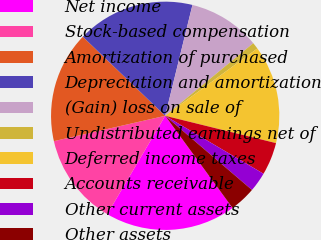<chart> <loc_0><loc_0><loc_500><loc_500><pie_chart><fcel>Net income<fcel>Stock-based compensation<fcel>Amortization of purchased<fcel>Depreciation and amortization<fcel>(Gain) loss on sale of<fcel>Undistributed earnings net of<fcel>Deferred income taxes<fcel>Accounts receivable<fcel>Other current assets<fcel>Other assets<nl><fcel>18.52%<fcel>12.96%<fcel>15.74%<fcel>16.67%<fcel>10.19%<fcel>0.93%<fcel>13.89%<fcel>4.63%<fcel>2.78%<fcel>3.7%<nl></chart> 